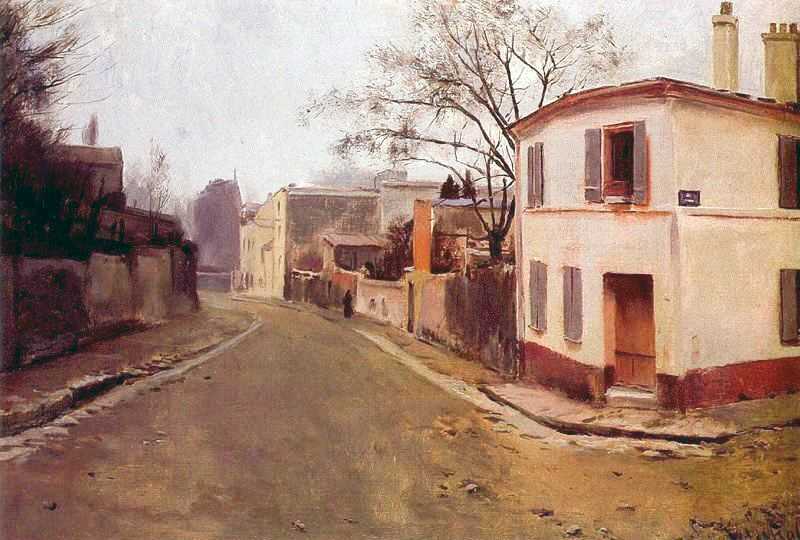How does this painting evoke the spirit of the time period it represents? This painting evokes the spirit of the late 19th to early 20th century through its impressionist style, muted color palette, and serene subject matter. The impressionist style, popular during this period, focuses on capturing the essence of a scene rather than precise details. The muted colors and quiet street convey a sense of simplicity and peace, reflective of rural or small-town life at the time. The absence of modern elements such as cars or electric lighting helps transport the viewer back in time, highlighting the slower pace of life and the calmness of an era before the rapid industrialization and urbanization of the 20th century. 